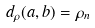<formula> <loc_0><loc_0><loc_500><loc_500>d _ { \rho } ( a , b ) = \rho _ { n }</formula> 